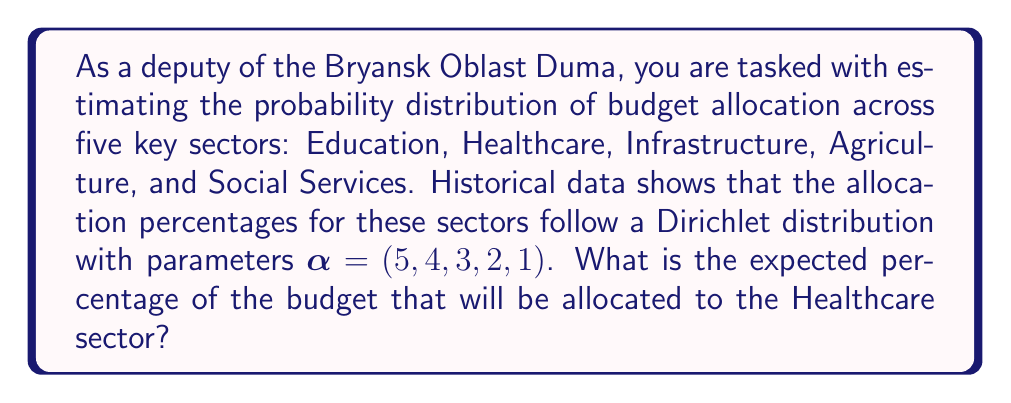Teach me how to tackle this problem. To solve this problem, we need to understand the properties of the Dirichlet distribution and how to calculate the expected value for one of its components.

1) The Dirichlet distribution is a multivariate probability distribution often used to describe the probability of allocation among multiple categories.

2) For a Dirichlet distribution with parameters $\alpha = (\alpha_1, \alpha_2, ..., \alpha_k)$, the expected value for the i-th component is given by:

   $$E[X_i] = \frac{\alpha_i}{\sum_{j=1}^k \alpha_j}$$

3) In our case, we have:
   $\alpha = (5, 4, 3, 2, 1)$
   Healthcare corresponds to the second component ($i = 2$), so $\alpha_2 = 4$

4) First, let's calculate the sum of all $\alpha$ values:
   $$\sum_{j=1}^k \alpha_j = 5 + 4 + 3 + 2 + 1 = 15$$

5) Now, we can apply the formula for the expected value:

   $$E[X_2] = \frac{\alpha_2}{\sum_{j=1}^k \alpha_j} = \frac{4}{15}$$

6) To convert this to a percentage, we multiply by 100:

   $$E[X_2] \cdot 100\% = \frac{4}{15} \cdot 100\% = 26.67\%$$

Therefore, the expected percentage of the budget that will be allocated to the Healthcare sector is approximately 26.67%.
Answer: 26.67% 